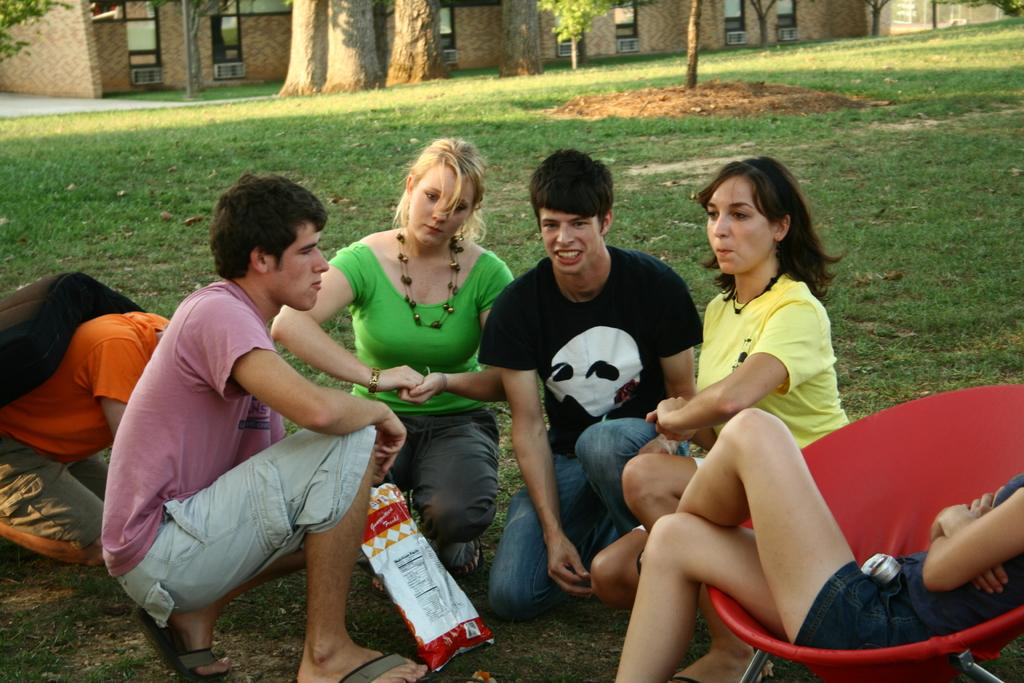What are the people in the image doing? The people in the image are sitting in the garden. What can be seen in the background of the image? There are plants, trees, grass, and sand in the background of the image. What type of coach can be seen in the image? There is no coach present in the image. What is the value of the copper in the image? There is no copper present in the image. 